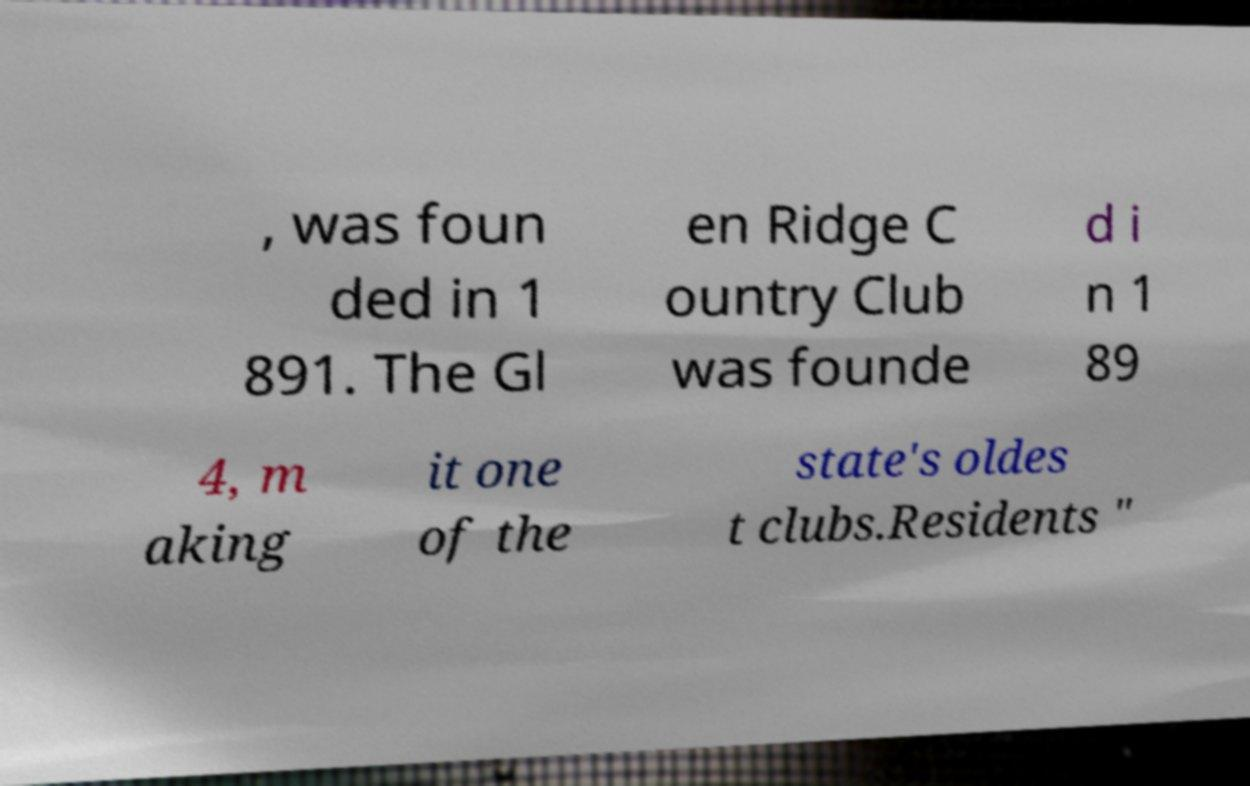For documentation purposes, I need the text within this image transcribed. Could you provide that? , was foun ded in 1 891. The Gl en Ridge C ountry Club was founde d i n 1 89 4, m aking it one of the state's oldes t clubs.Residents " 